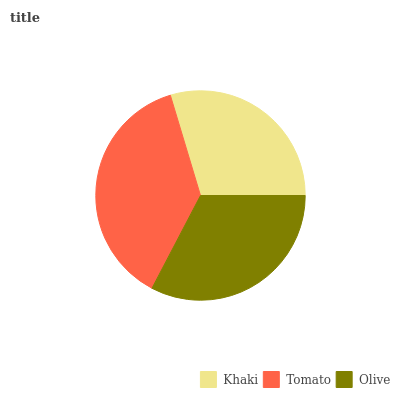Is Khaki the minimum?
Answer yes or no. Yes. Is Tomato the maximum?
Answer yes or no. Yes. Is Olive the minimum?
Answer yes or no. No. Is Olive the maximum?
Answer yes or no. No. Is Tomato greater than Olive?
Answer yes or no. Yes. Is Olive less than Tomato?
Answer yes or no. Yes. Is Olive greater than Tomato?
Answer yes or no. No. Is Tomato less than Olive?
Answer yes or no. No. Is Olive the high median?
Answer yes or no. Yes. Is Olive the low median?
Answer yes or no. Yes. Is Khaki the high median?
Answer yes or no. No. Is Tomato the low median?
Answer yes or no. No. 